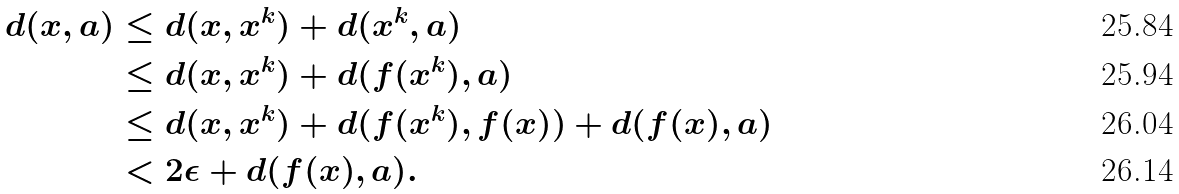Convert formula to latex. <formula><loc_0><loc_0><loc_500><loc_500>d ( x , a ) & \leq d ( x , x ^ { k } ) + d ( x ^ { k } , a ) \\ & \leq d ( x , x ^ { k } ) + d ( f ( x ^ { k } ) , a ) \\ & \leq d ( x , x ^ { k } ) + d ( f ( x ^ { k } ) , f ( x ) ) + d ( f ( x ) , a ) \\ & < 2 \epsilon + d ( f ( x ) , a ) .</formula> 